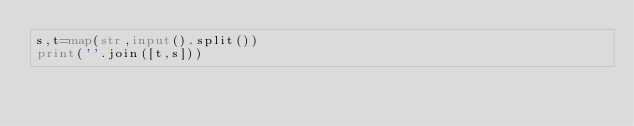<code> <loc_0><loc_0><loc_500><loc_500><_Python_>s,t=map(str,input().split())
print(''.join([t,s]))</code> 